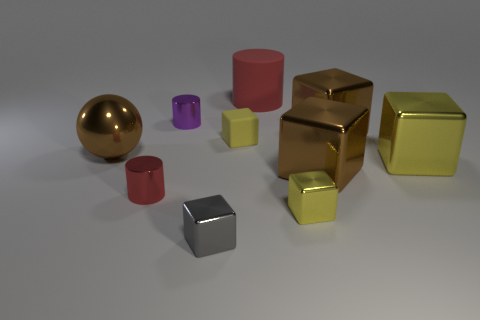What number of other objects are the same color as the big shiny ball?
Keep it short and to the point. 2. Is the material of the large brown block in front of the shiny sphere the same as the red thing right of the tiny rubber cube?
Your response must be concise. No. Are there fewer metallic things on the right side of the small gray metallic object than cyan metallic spheres?
Offer a very short reply. No. Are there any other things that have the same shape as the large yellow object?
Make the answer very short. Yes. The tiny matte thing that is the same shape as the gray metal object is what color?
Your answer should be compact. Yellow. Do the metal cylinder in front of the purple cylinder and the big metal ball have the same size?
Your response must be concise. No. What is the size of the brown thing to the left of the big thing behind the purple thing?
Make the answer very short. Large. Is the large red object made of the same material as the large brown object that is in front of the large brown ball?
Your response must be concise. No. Are there fewer tiny gray metallic blocks that are left of the brown ball than red shiny things that are on the left side of the big red cylinder?
Provide a short and direct response. Yes. What color is the cube that is the same material as the large cylinder?
Give a very brief answer. Yellow. 